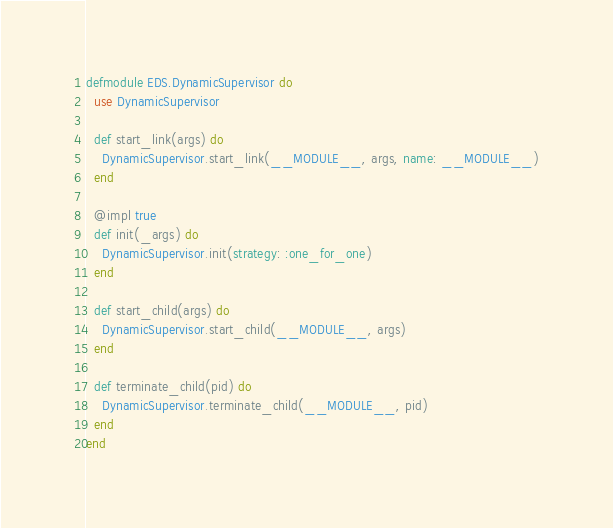Convert code to text. <code><loc_0><loc_0><loc_500><loc_500><_Elixir_>defmodule EDS.DynamicSupervisor do
  use DynamicSupervisor

  def start_link(args) do
    DynamicSupervisor.start_link(__MODULE__, args, name: __MODULE__)
  end

  @impl true
  def init(_args) do
    DynamicSupervisor.init(strategy: :one_for_one)
  end

  def start_child(args) do
    DynamicSupervisor.start_child(__MODULE__, args)
  end

  def terminate_child(pid) do
    DynamicSupervisor.terminate_child(__MODULE__, pid)
  end
end
</code> 